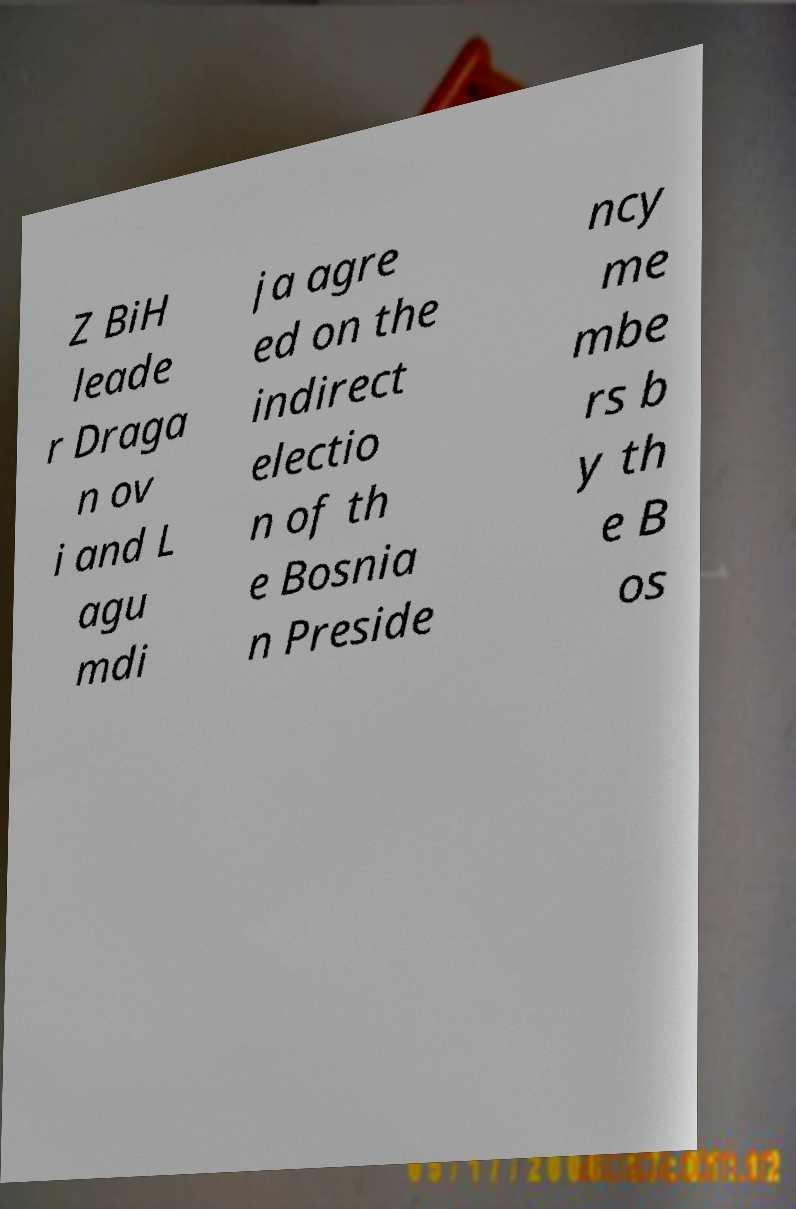Can you read and provide the text displayed in the image?This photo seems to have some interesting text. Can you extract and type it out for me? Z BiH leade r Draga n ov i and L agu mdi ja agre ed on the indirect electio n of th e Bosnia n Preside ncy me mbe rs b y th e B os 